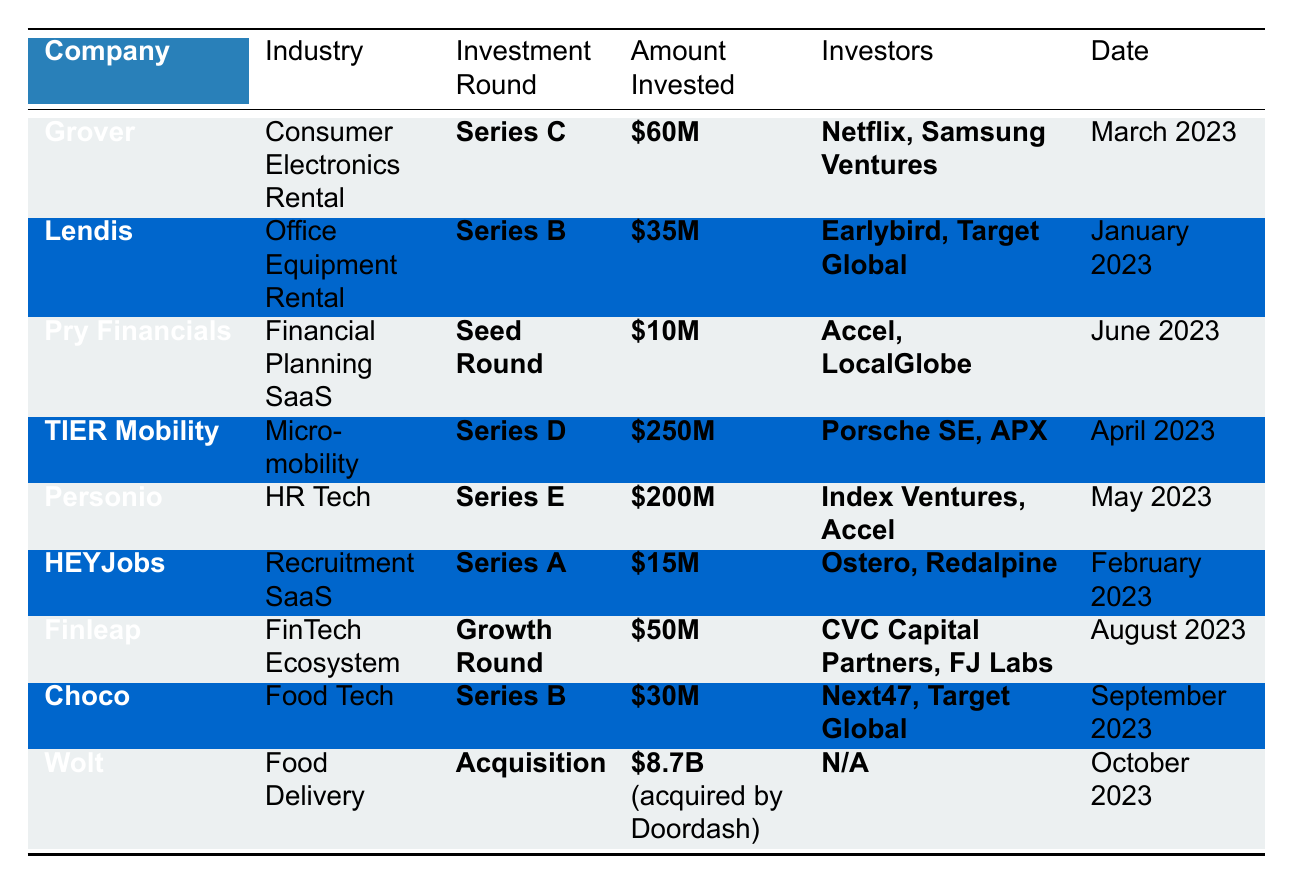What is the highest amount invested in a single company? The table shows that the highest amount invested is **$8.7B**, which was for **Wolt** as part of an acquisition by Doordash in October 2023.
Answer: $8.7B How many companies secured funding in Series B? A total of **3 companies** received Series B funding: **Lendis**, **Choco**, and **TIER Mobility**.
Answer: 3 Who were the investors in Personio? The investors in **Personio** were **Index Ventures** and **Accel** as stated in the table.
Answer: Index Ventures, Accel What is the total amount invested across all startups listed in the table? The total can be calculated by summing the amounts: $60M (Grover) + $35M (Lendis) + $10M (Pry Financials) + $250M (TIER Mobility) + $200M (Personio) + $15M (HEYJobs) + $50M (Finleap) + $30M (Choco) + $8.7B (Wolt) = $9.4B.
Answer: $9.4B Was there any investment in the Food Delivery industry? Yes, **Wolt** received a significant investment of **$8.7B**, which was an acquisition by Doordash.
Answer: Yes Which company raised the least amount of investment? **Pry Financials** raised the least amount with **$10M** in their Seed Round in June 2023.
Answer: $10M What month saw the highest collective investment in Berlin tech startups in 2023? **April 2023** had the most substantial investment with **$250M** going to **TIER Mobility** and contributed to the total, but also considering other months, the sum could exceed this for multiple startups funded.
Answer: April 2023 If you combined the investments from Series D and E, what would be the total? The total would be $250M (TIER Mobility, Series D) + $200M (Personio, Series E) = $450M.
Answer: $450M How many different industries were represented in the investment data? There are **8 different industries** represented in the table: Consumer Electronics Rental, Office Equipment Rental, Financial Planning SaaS, Micro-mobility, HR Tech, Recruitment SaaS, FinTech Ecosystem, and Food Delivery.
Answer: 8 Who are the investors in the largest funding round? The largest funding round, which is **$8.7B** for **Wolt**, listed **N/A** for investors due to it being an acquisition.
Answer: N/A 